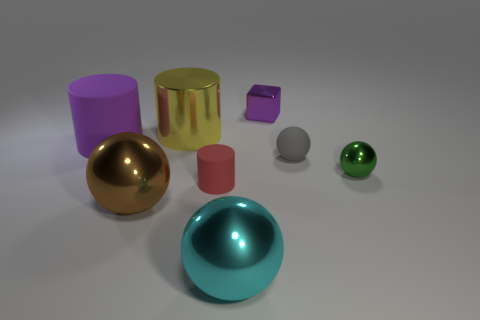Subtract all large cylinders. How many cylinders are left? 1 Subtract 1 cylinders. How many cylinders are left? 2 Add 2 small blue rubber spheres. How many objects exist? 10 Subtract all cyan spheres. How many spheres are left? 3 Subtract all cylinders. How many objects are left? 5 Subtract all green spheres. Subtract all yellow cylinders. How many spheres are left? 3 Add 2 yellow metal objects. How many yellow metal objects exist? 3 Subtract 1 brown balls. How many objects are left? 7 Subtract all small purple blocks. Subtract all red matte cylinders. How many objects are left? 6 Add 8 tiny red cylinders. How many tiny red cylinders are left? 9 